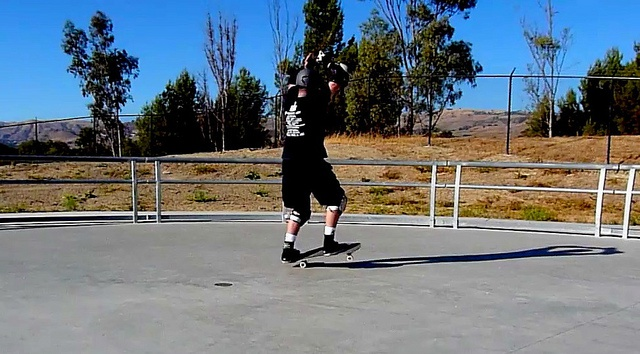Describe the objects in this image and their specific colors. I can see people in gray, black, white, and darkgray tones, skateboard in gray, black, darkgray, and lightgray tones, and skateboard in gray, darkgray, black, and lightgray tones in this image. 